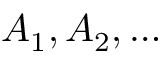<formula> <loc_0><loc_0><loc_500><loc_500>A _ { 1 } , A _ { 2 } , \dots</formula> 